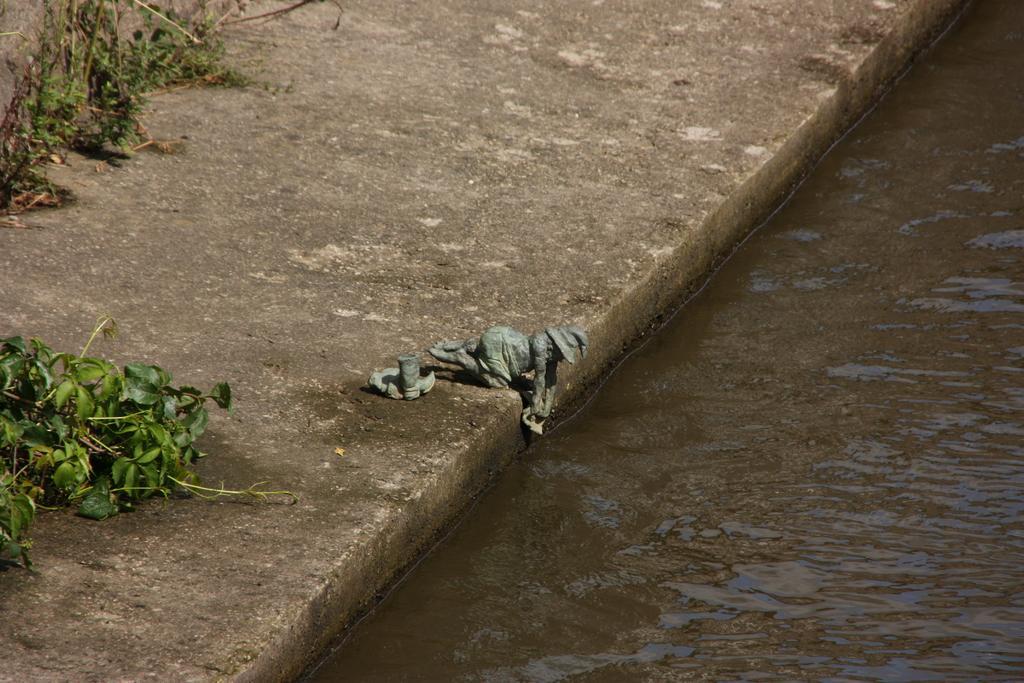Can you describe this image briefly? In this image we can see statues on the floor, creepers, plants and water. 